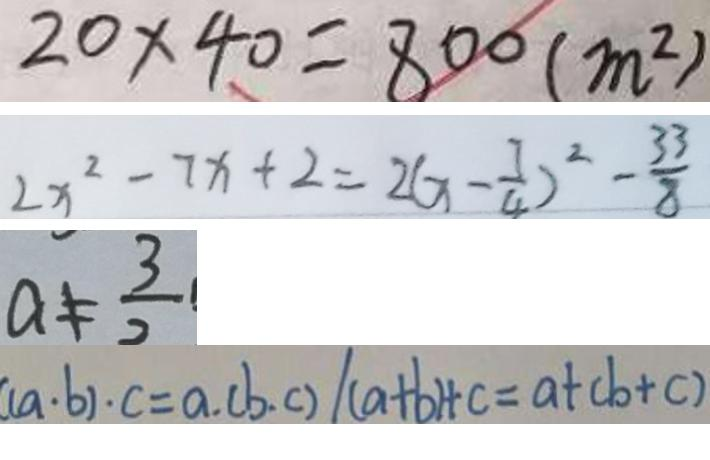<formula> <loc_0><loc_0><loc_500><loc_500>2 0 \times 4 0 = 8 0 0 ( m ^ { 2 } ) 
 2 x ^ { 2 } - 7 x + 2 = 2 ( x - \frac { 7 } { 4 } ) ^ { 2 } - \frac { 3 3 } { 8 } 
 a \neq \frac { 3 } { 2 } 
 ( a \cdot b ) \cdot c = a . ( b . c ) / ( a + b ) + c = a + ( b + c )</formula> 